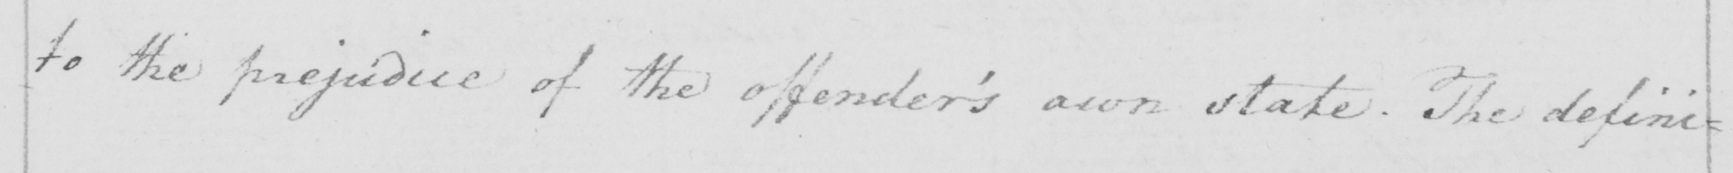Can you read and transcribe this handwriting? to the prejudice of the offender ' s own state . The defini= 